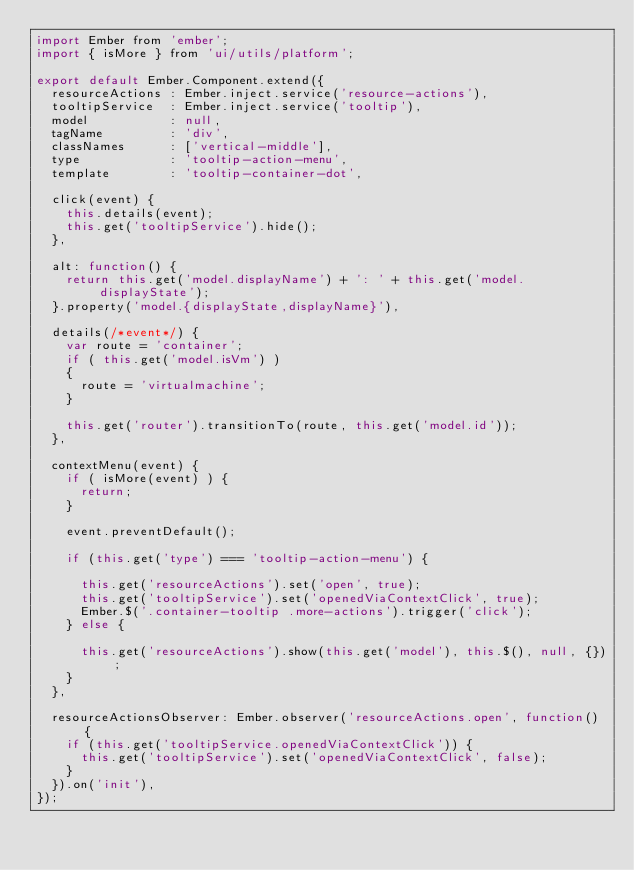Convert code to text. <code><loc_0><loc_0><loc_500><loc_500><_JavaScript_>import Ember from 'ember';
import { isMore } from 'ui/utils/platform';

export default Ember.Component.extend({
  resourceActions : Ember.inject.service('resource-actions'),
  tooltipService  : Ember.inject.service('tooltip'),
  model           : null,
  tagName         : 'div',
  classNames      : ['vertical-middle'],
  type            : 'tooltip-action-menu',
  template        : 'tooltip-container-dot',

  click(event) {
    this.details(event);
    this.get('tooltipService').hide();
  },

  alt: function() {
    return this.get('model.displayName') + ': ' + this.get('model.displayState');
  }.property('model.{displayState,displayName}'),

  details(/*event*/) {
    var route = 'container';
    if ( this.get('model.isVm') )
    {
      route = 'virtualmachine';
    }

    this.get('router').transitionTo(route, this.get('model.id'));
  },

  contextMenu(event) {
    if ( isMore(event) ) {
      return;
    }

    event.preventDefault();

    if (this.get('type') === 'tooltip-action-menu') {

      this.get('resourceActions').set('open', true);
      this.get('tooltipService').set('openedViaContextClick', true);
      Ember.$('.container-tooltip .more-actions').trigger('click');
    } else {

      this.get('resourceActions').show(this.get('model'), this.$(), null, {});
    }
  },

  resourceActionsObserver: Ember.observer('resourceActions.open', function() {
    if (this.get('tooltipService.openedViaContextClick')) {
      this.get('tooltipService').set('openedViaContextClick', false);
    }
  }).on('init'),
});
</code> 